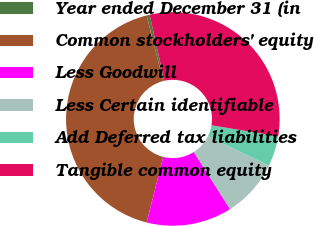Convert chart. <chart><loc_0><loc_0><loc_500><loc_500><pie_chart><fcel>Year ended December 31 (in<fcel>Common stockholders' equity<fcel>Less Goodwill<fcel>Less Certain identifiable<fcel>Add Deferred tax liabilities<fcel>Tangible common equity<nl><fcel>0.46%<fcel>42.1%<fcel>12.95%<fcel>8.79%<fcel>4.62%<fcel>31.08%<nl></chart> 